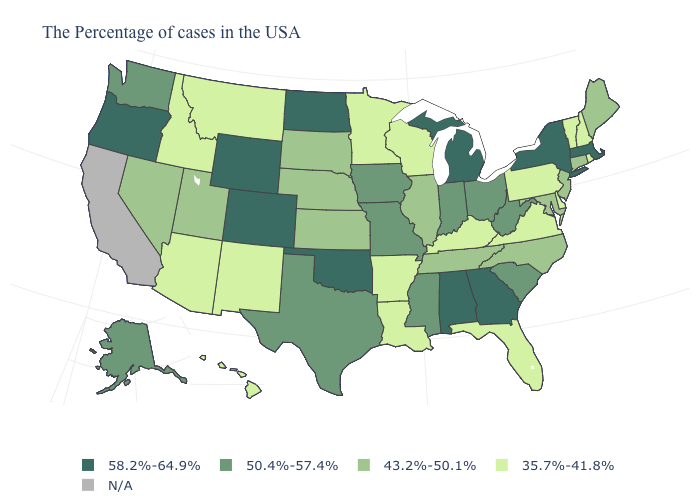Name the states that have a value in the range 43.2%-50.1%?
Keep it brief. Maine, Connecticut, New Jersey, Maryland, North Carolina, Tennessee, Illinois, Kansas, Nebraska, South Dakota, Utah, Nevada. What is the value of Wisconsin?
Give a very brief answer. 35.7%-41.8%. Name the states that have a value in the range 58.2%-64.9%?
Quick response, please. Massachusetts, New York, Georgia, Michigan, Alabama, Oklahoma, North Dakota, Wyoming, Colorado, Oregon. Name the states that have a value in the range 50.4%-57.4%?
Short answer required. South Carolina, West Virginia, Ohio, Indiana, Mississippi, Missouri, Iowa, Texas, Washington, Alaska. Name the states that have a value in the range 50.4%-57.4%?
Quick response, please. South Carolina, West Virginia, Ohio, Indiana, Mississippi, Missouri, Iowa, Texas, Washington, Alaska. Among the states that border Wisconsin , which have the lowest value?
Write a very short answer. Minnesota. Name the states that have a value in the range 35.7%-41.8%?
Quick response, please. Rhode Island, New Hampshire, Vermont, Delaware, Pennsylvania, Virginia, Florida, Kentucky, Wisconsin, Louisiana, Arkansas, Minnesota, New Mexico, Montana, Arizona, Idaho, Hawaii. What is the highest value in states that border North Carolina?
Be succinct. 58.2%-64.9%. Which states have the highest value in the USA?
Give a very brief answer. Massachusetts, New York, Georgia, Michigan, Alabama, Oklahoma, North Dakota, Wyoming, Colorado, Oregon. What is the value of Hawaii?
Short answer required. 35.7%-41.8%. What is the lowest value in the MidWest?
Concise answer only. 35.7%-41.8%. Name the states that have a value in the range 35.7%-41.8%?
Write a very short answer. Rhode Island, New Hampshire, Vermont, Delaware, Pennsylvania, Virginia, Florida, Kentucky, Wisconsin, Louisiana, Arkansas, Minnesota, New Mexico, Montana, Arizona, Idaho, Hawaii. What is the highest value in the USA?
Concise answer only. 58.2%-64.9%. Name the states that have a value in the range 43.2%-50.1%?
Answer briefly. Maine, Connecticut, New Jersey, Maryland, North Carolina, Tennessee, Illinois, Kansas, Nebraska, South Dakota, Utah, Nevada. 